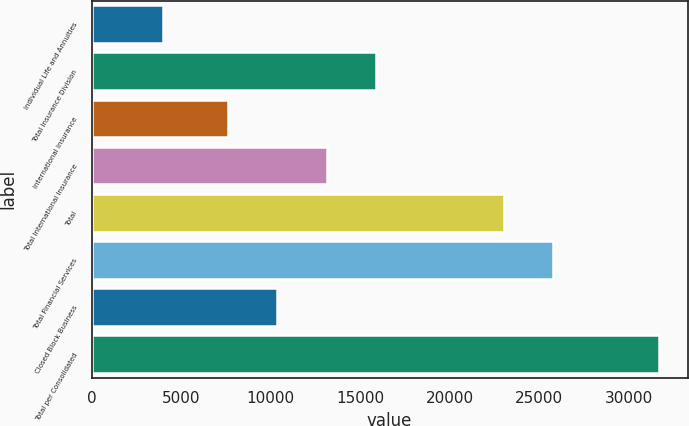Convert chart to OTSL. <chart><loc_0><loc_0><loc_500><loc_500><bar_chart><fcel>Individual Life and Annuities<fcel>Total Insurance Division<fcel>International Insurance<fcel>Total International Insurance<fcel>Total<fcel>Total Financial Services<fcel>Closed Block Business<fcel>Total per Consolidated<nl><fcel>4008<fcel>15905<fcel>7595<fcel>13135<fcel>23028<fcel>25798<fcel>10365<fcel>31708<nl></chart> 